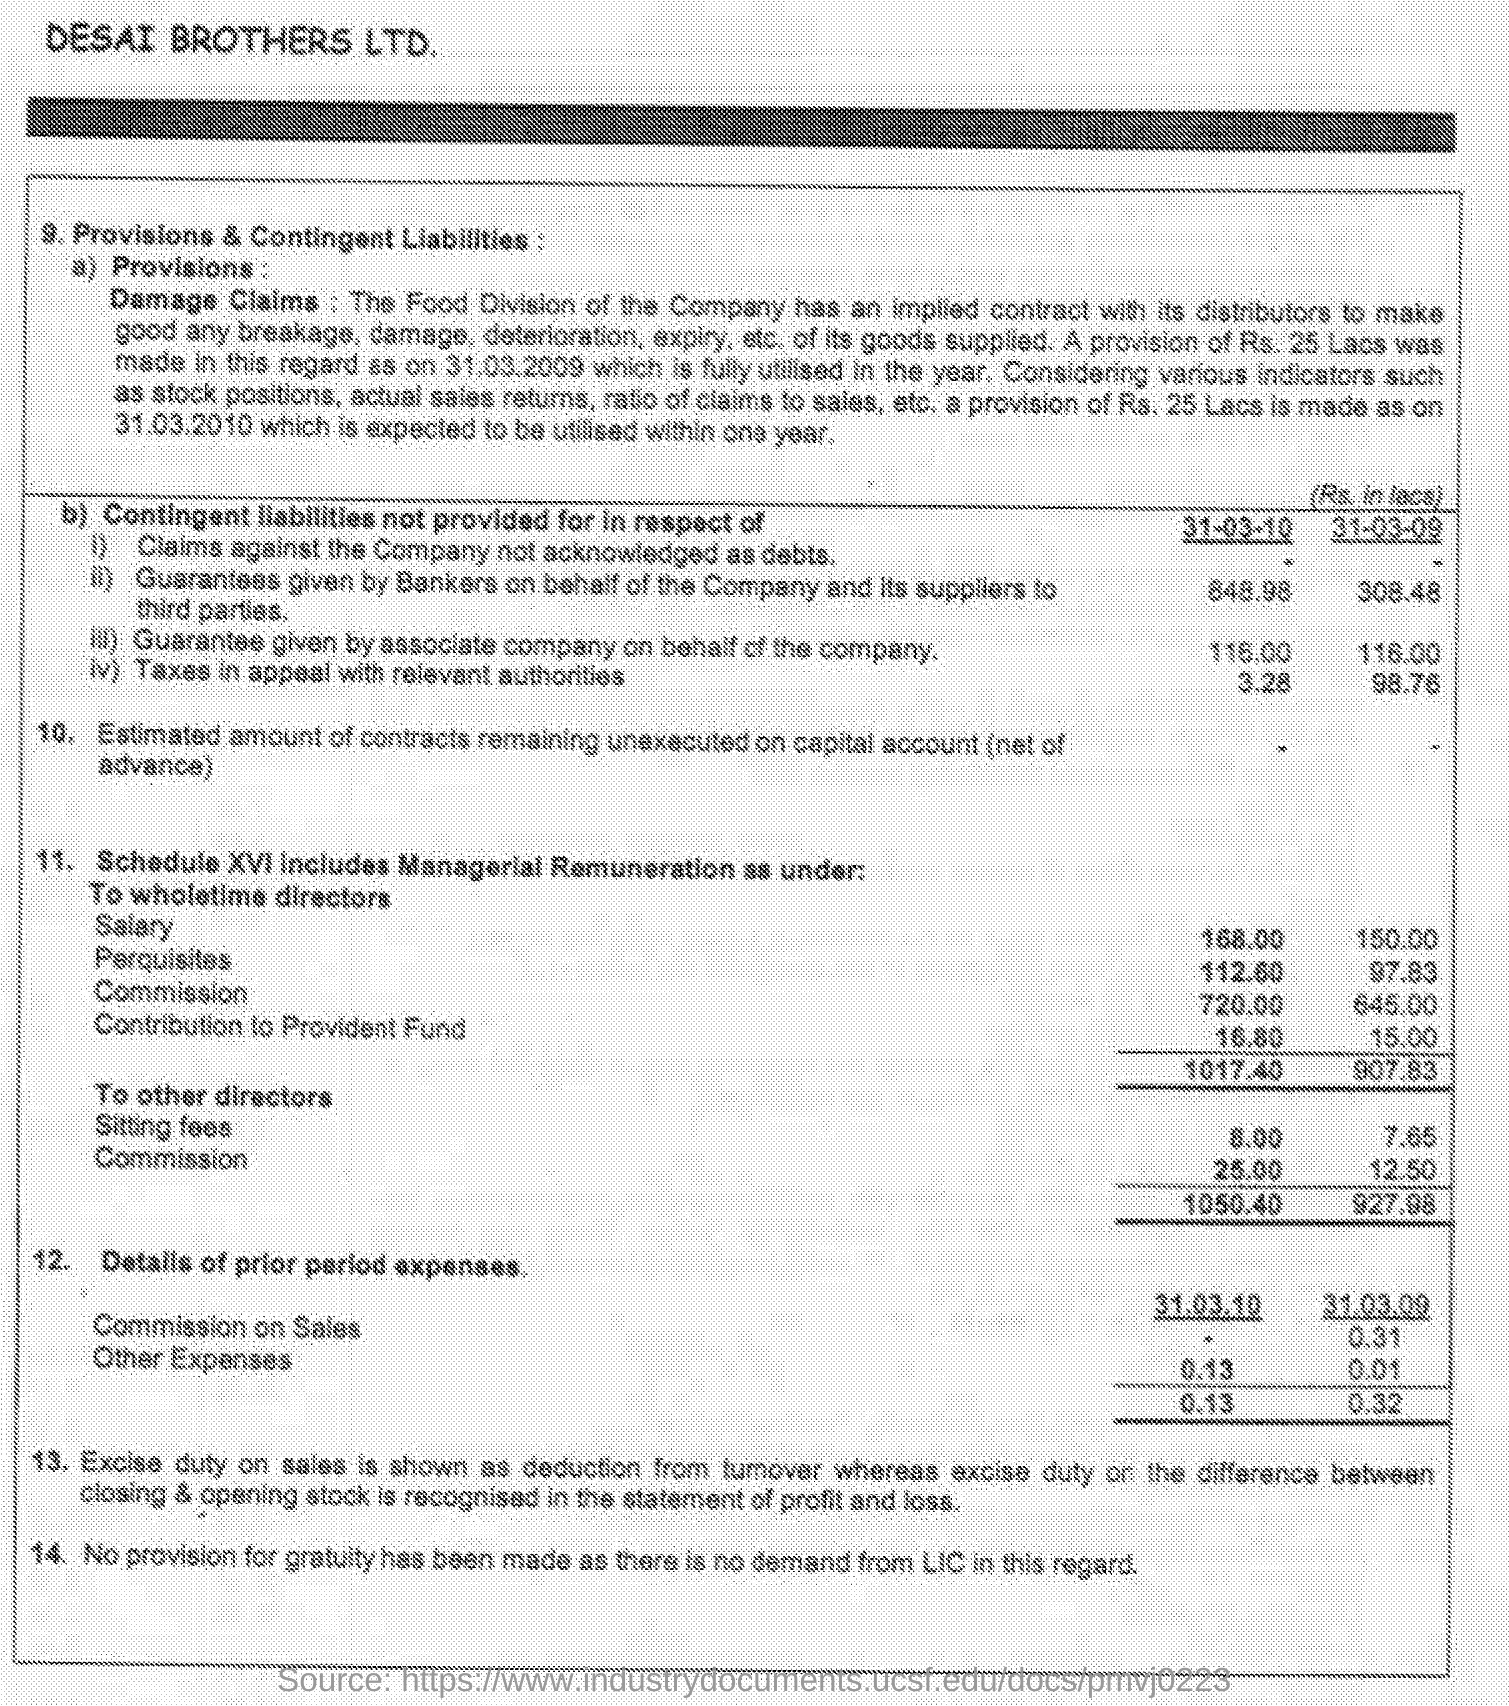Indicate a few pertinent items in this graphic. On March 31, 2009, the sitting fees were 7.65. On March 31, 2009, the perquisites were 97.83... On March 31st, 2010, the perquisite was 112.60. The sitting fee for March 31, 2010, is 8.00. 